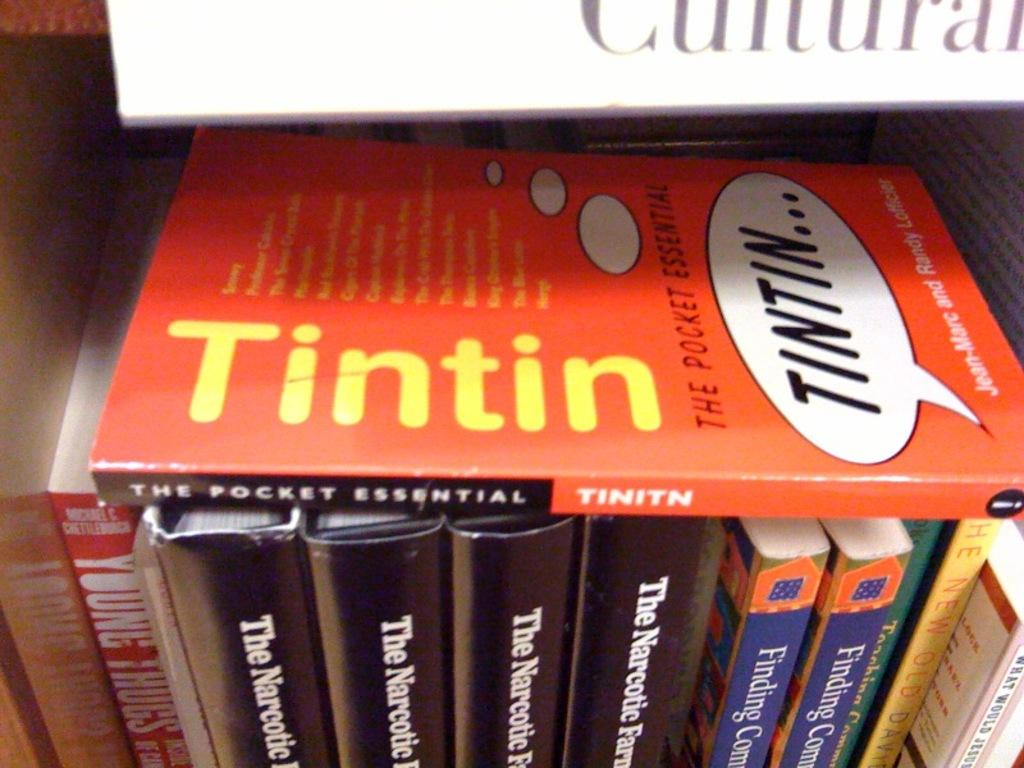<image>
Give a short and clear explanation of the subsequent image. A book shelf with multiple books and a book called Tintin laying across them. 